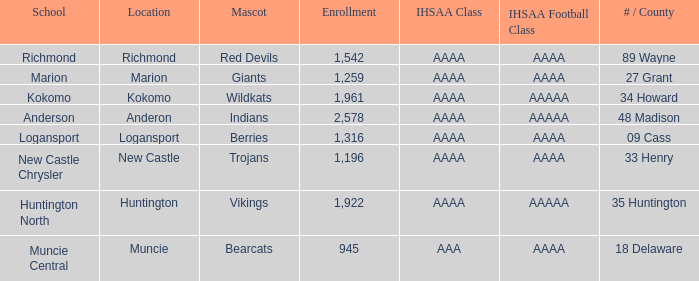What's the IHSAA class of the Red Devils? AAAA. 